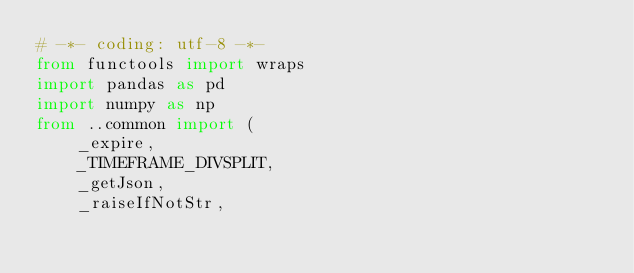<code> <loc_0><loc_0><loc_500><loc_500><_Python_># -*- coding: utf-8 -*-
from functools import wraps
import pandas as pd
import numpy as np
from ..common import (
    _expire,
    _TIMEFRAME_DIVSPLIT,
    _getJson,
    _raiseIfNotStr,</code> 